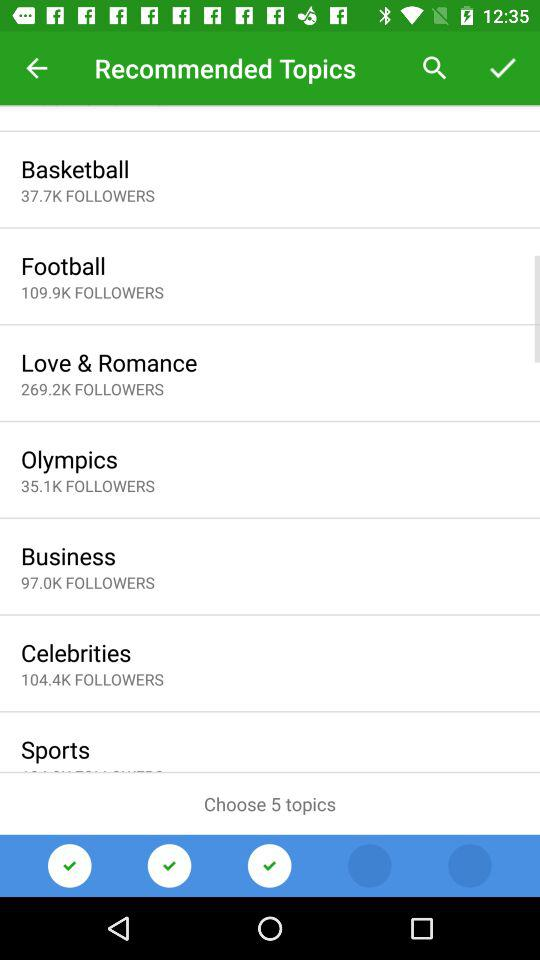Which topic has 109.9K followers? The topic that has 109.9K followers is "Football". 